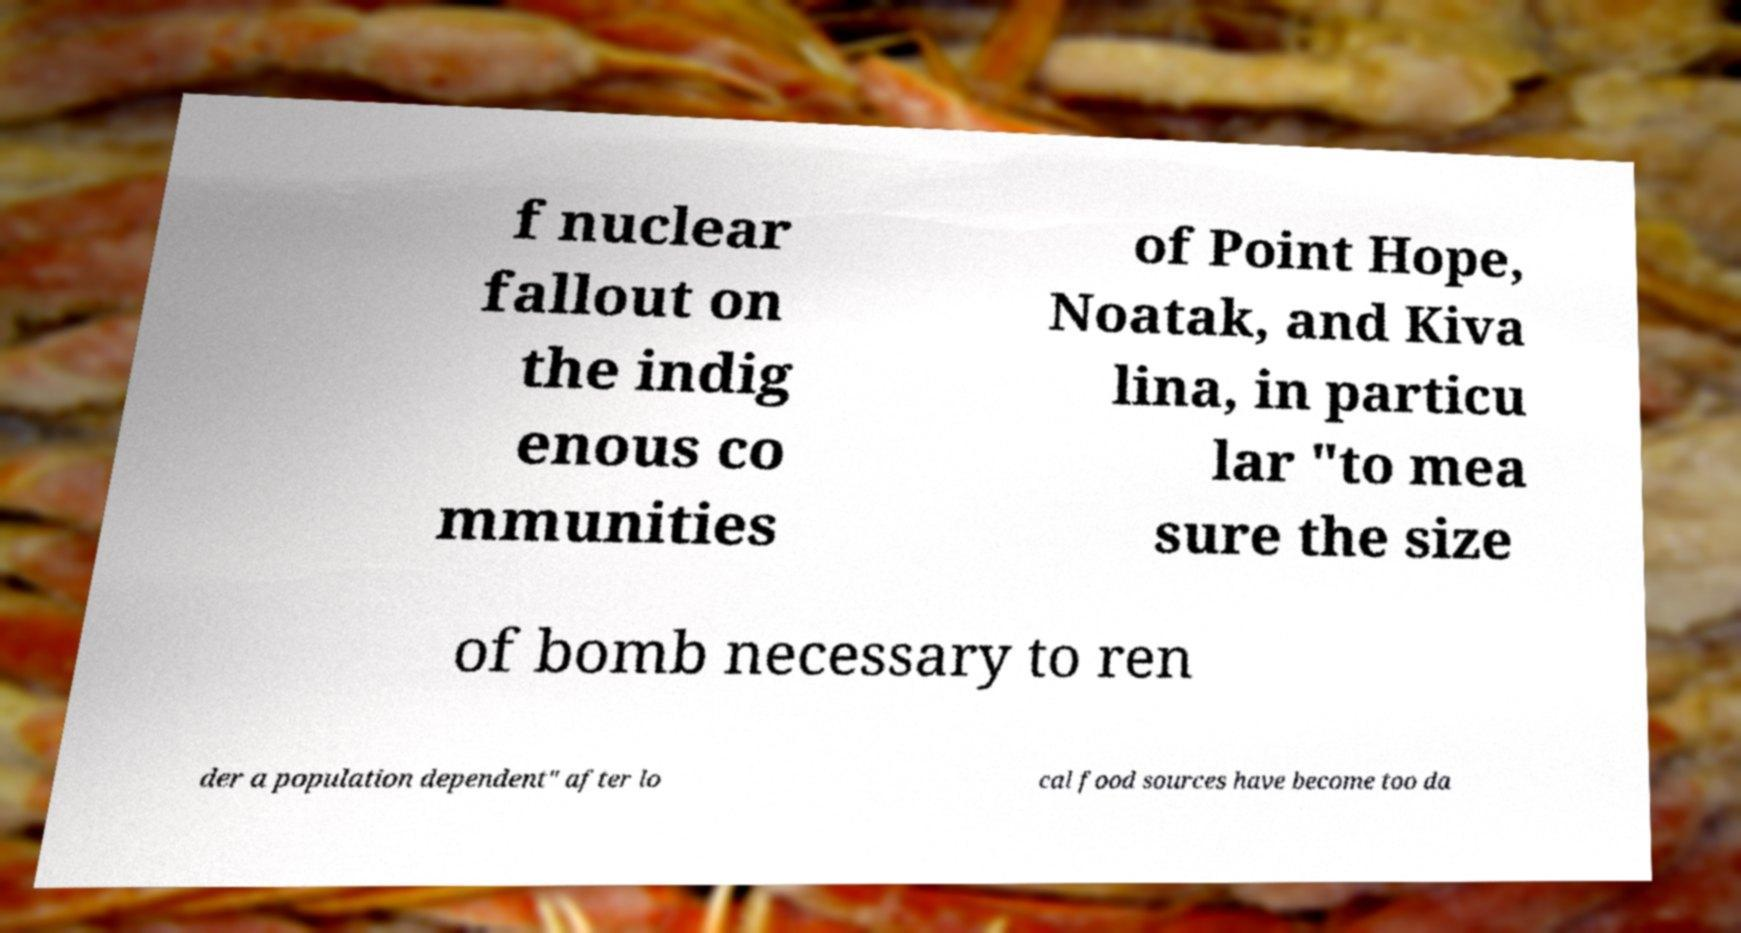What messages or text are displayed in this image? I need them in a readable, typed format. f nuclear fallout on the indig enous co mmunities of Point Hope, Noatak, and Kiva lina, in particu lar "to mea sure the size of bomb necessary to ren der a population dependent" after lo cal food sources have become too da 